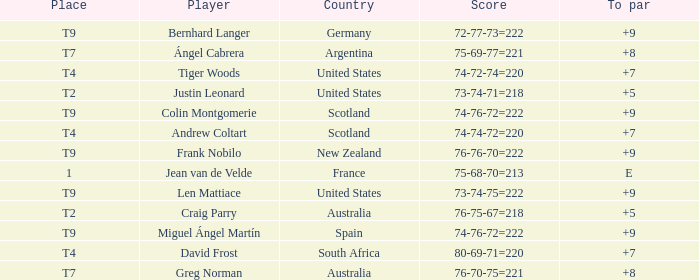Which player from the United States is in a place of T2? Justin Leonard. Would you mind parsing the complete table? {'header': ['Place', 'Player', 'Country', 'Score', 'To par'], 'rows': [['T9', 'Bernhard Langer', 'Germany', '72-77-73=222', '+9'], ['T7', 'Ángel Cabrera', 'Argentina', '75-69-77=221', '+8'], ['T4', 'Tiger Woods', 'United States', '74-72-74=220', '+7'], ['T2', 'Justin Leonard', 'United States', '73-74-71=218', '+5'], ['T9', 'Colin Montgomerie', 'Scotland', '74-76-72=222', '+9'], ['T4', 'Andrew Coltart', 'Scotland', '74-74-72=220', '+7'], ['T9', 'Frank Nobilo', 'New Zealand', '76-76-70=222', '+9'], ['1', 'Jean van de Velde', 'France', '75-68-70=213', 'E'], ['T9', 'Len Mattiace', 'United States', '73-74-75=222', '+9'], ['T2', 'Craig Parry', 'Australia', '76-75-67=218', '+5'], ['T9', 'Miguel Ángel Martín', 'Spain', '74-76-72=222', '+9'], ['T4', 'David Frost', 'South Africa', '80-69-71=220', '+7'], ['T7', 'Greg Norman', 'Australia', '76-70-75=221', '+8']]} 